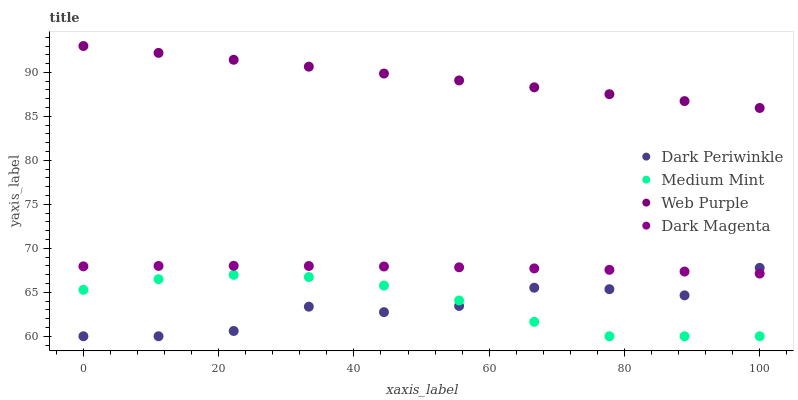Does Dark Periwinkle have the minimum area under the curve?
Answer yes or no. Yes. Does Web Purple have the maximum area under the curve?
Answer yes or no. Yes. Does Web Purple have the minimum area under the curve?
Answer yes or no. No. Does Dark Periwinkle have the maximum area under the curve?
Answer yes or no. No. Is Web Purple the smoothest?
Answer yes or no. Yes. Is Dark Periwinkle the roughest?
Answer yes or no. Yes. Is Dark Periwinkle the smoothest?
Answer yes or no. No. Is Web Purple the roughest?
Answer yes or no. No. Does Medium Mint have the lowest value?
Answer yes or no. Yes. Does Web Purple have the lowest value?
Answer yes or no. No. Does Web Purple have the highest value?
Answer yes or no. Yes. Does Dark Periwinkle have the highest value?
Answer yes or no. No. Is Dark Magenta less than Web Purple?
Answer yes or no. Yes. Is Dark Magenta greater than Medium Mint?
Answer yes or no. Yes. Does Medium Mint intersect Dark Periwinkle?
Answer yes or no. Yes. Is Medium Mint less than Dark Periwinkle?
Answer yes or no. No. Is Medium Mint greater than Dark Periwinkle?
Answer yes or no. No. Does Dark Magenta intersect Web Purple?
Answer yes or no. No. 